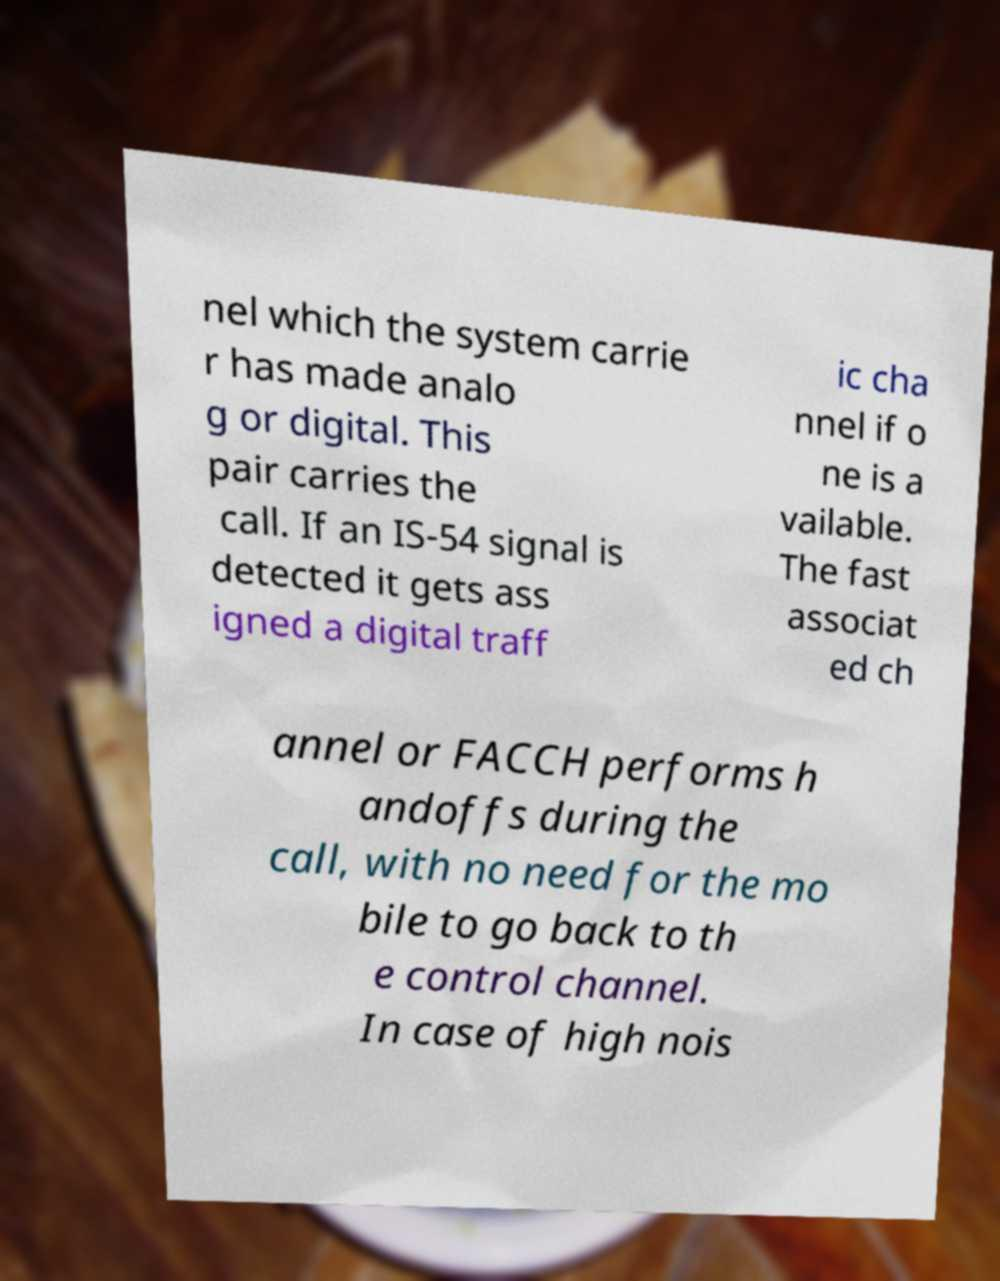I need the written content from this picture converted into text. Can you do that? nel which the system carrie r has made analo g or digital. This pair carries the call. If an IS-54 signal is detected it gets ass igned a digital traff ic cha nnel if o ne is a vailable. The fast associat ed ch annel or FACCH performs h andoffs during the call, with no need for the mo bile to go back to th e control channel. In case of high nois 